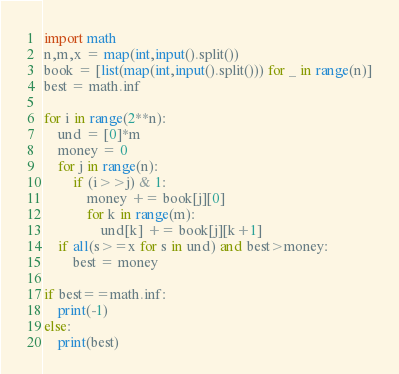<code> <loc_0><loc_0><loc_500><loc_500><_Python_>import math
n,m,x = map(int,input().split())
book = [list(map(int,input().split())) for _ in range(n)]
best = math.inf

for i in range(2**n):
    und = [0]*m
    money = 0
    for j in range(n):
        if (i>>j) & 1:
            money += book[j][0]
            for k in range(m):
                und[k] += book[j][k+1]
    if all(s>=x for s in und) and best>money:
        best = money

if best==math.inf:
    print(-1)
else:
    print(best)</code> 